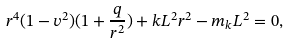<formula> <loc_0><loc_0><loc_500><loc_500>r ^ { 4 } ( 1 - v ^ { 2 } ) ( 1 + \frac { q } { r ^ { 2 } } ) + k L ^ { 2 } r ^ { 2 } - m _ { k } L ^ { 2 } = 0 ,</formula> 